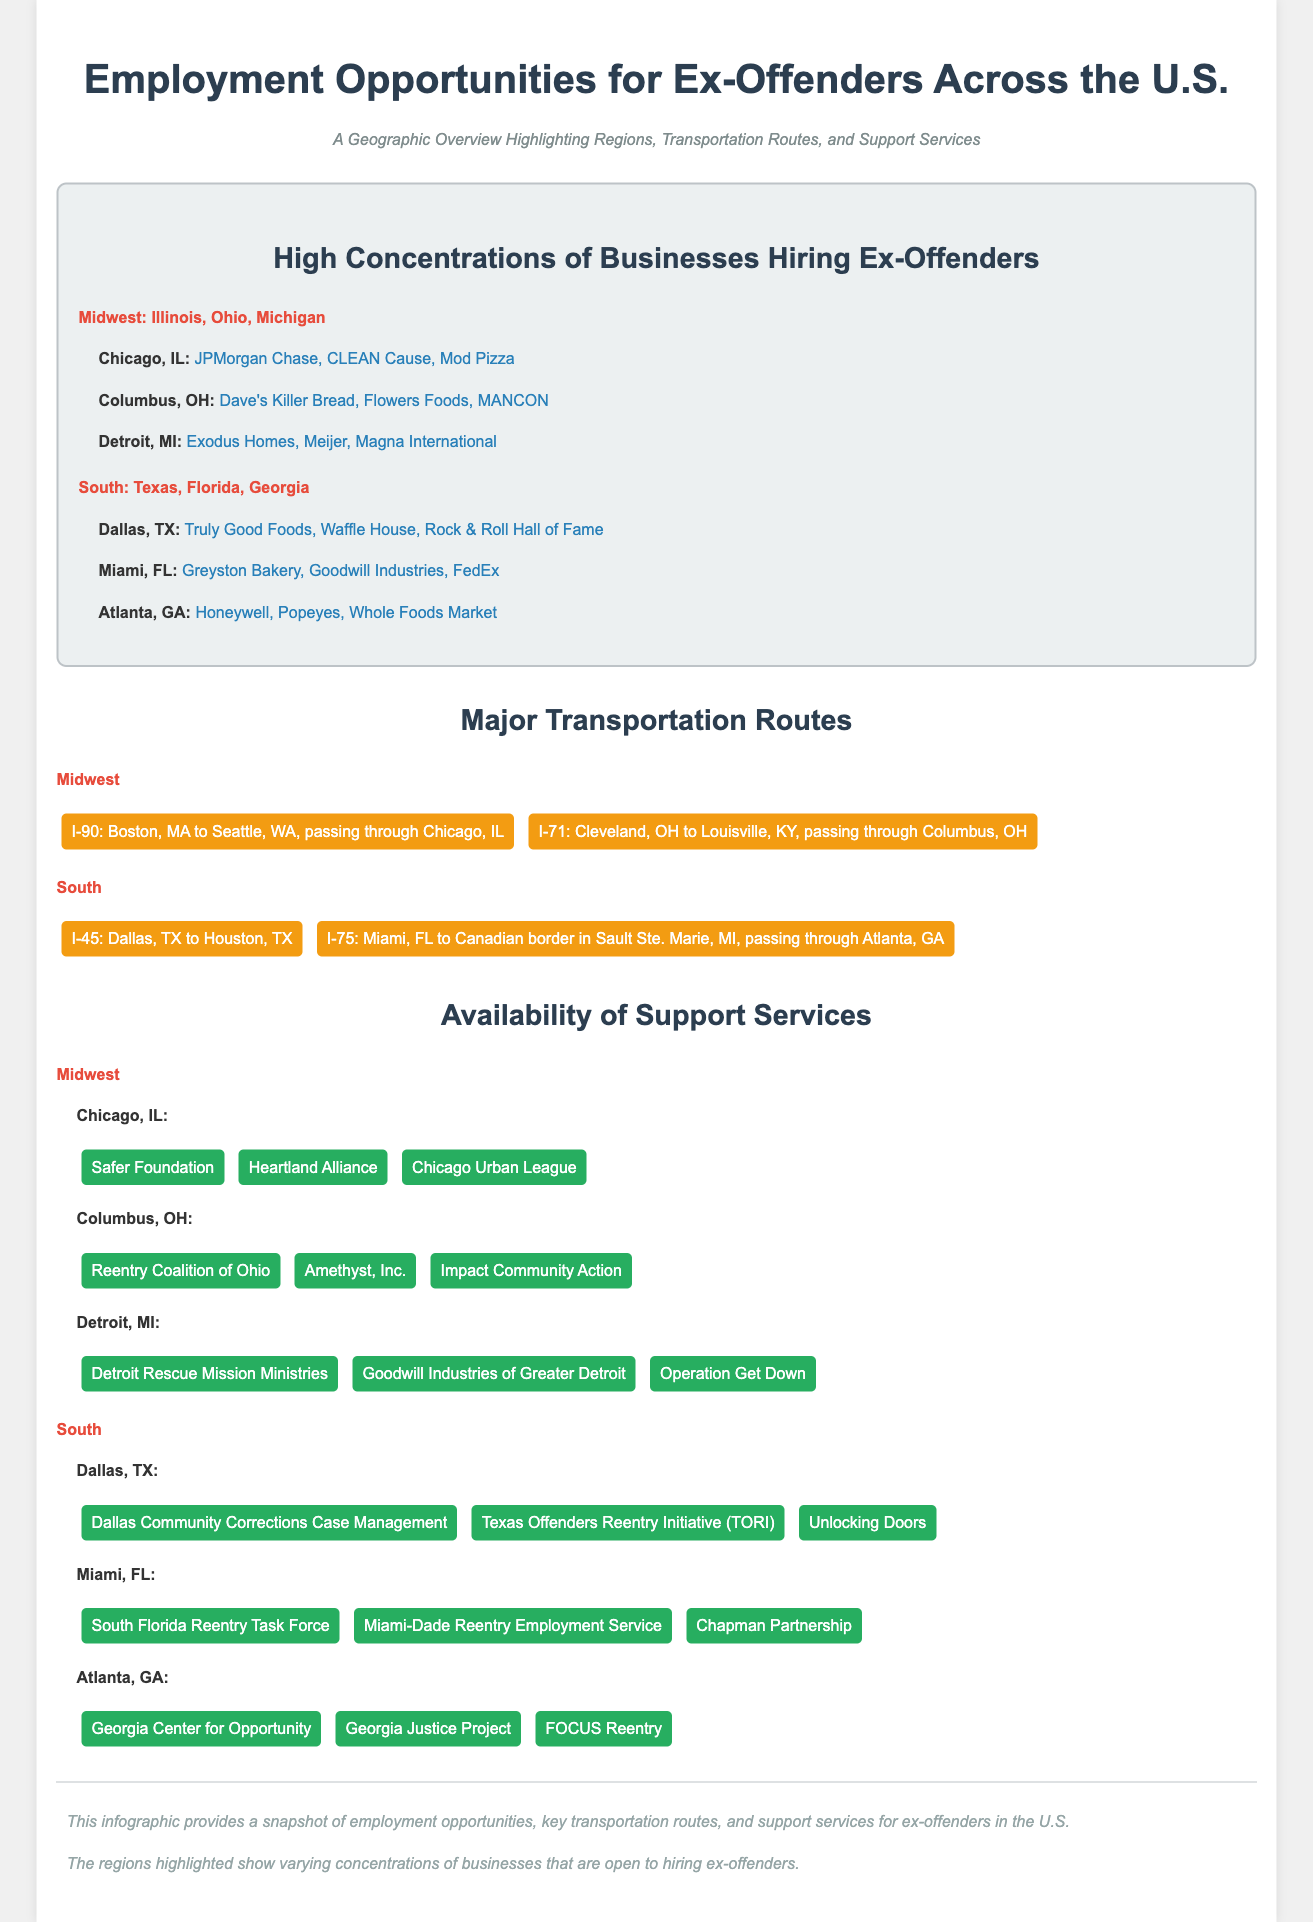what regions in the U.S. are highlighted for high concentrations of businesses hiring ex-offenders? The regions highlighted are the Midwest and South.
Answer: Midwest, South name a business in Chicago that hires ex-offenders. The document lists several businesses in Chicago that hire ex-offenders, including JPMorgan Chase.
Answer: JPMorgan Chase which support center is located in Miami, FL? The document mentions several support centers available in Miami, such as the South Florida Reentry Task Force.
Answer: South Florida Reentry Task Force how many cities are mentioned in the Midwest region for employment opportunities? The document lists three cities in the Midwest region for employment opportunities: Chicago, Columbus, and Detroit.
Answer: 3 what major transportation route runs through Atlanta, GA? The document indicates that I-75 runs through Atlanta, GA.
Answer: I-75 which company in Dallas, TX is mentioned as hiring ex-offenders? The document provides several companies that hire ex-offenders in Dallas, including Truly Good Foods.
Answer: Truly Good Foods what type of document is this? The content focuses on geographic data related to employment opportunities for ex-offenders.
Answer: Geographic infographic name one key transportation route in the South. The document lists I-45 as a major transportation route in the South.
Answer: I-45 what is the main purpose of this infographic? The infographic aims to provide a snapshot of employment opportunities and support services for ex-offenders in the U.S.
Answer: Employment opportunities for ex-offenders 